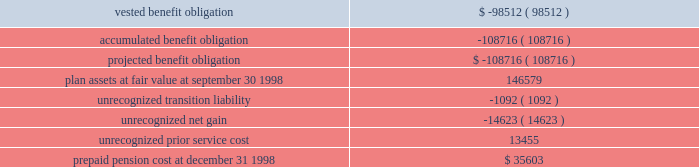The containerboard group ( a division of tenneco packaging inc. ) notes to combined financial statements ( continued ) april 11 , 1999 5 .
Pension and other benefit plans ( continued ) the funded status of the group 2019s allocation of defined benefit plans , excluding the retirement plan , reconciles with amounts recognized in the 1998 statements of assets and liabilities and interdivision account as follows ( in thousands ) : actuarial present value at september 30 , 1998 2014 .
The weighted average discount rate used in determining the actuarial present value of the benefit obligations was 7.00% ( 7.00 % ) for the year ended december 31 , 1998 .
The weighted average expected long-term rate of return on plan assets was 10% ( 10 % ) for 1998 .
Middle management employees participate in a variety of incentive compensation plans .
These plans provide for incentive payments based on the achievement of certain targeted operating results and other specific business goals .
The targeted operating results are determined each year by senior management of packaging .
The amounts charged to expense for these plans were $ 1599000 for the period ended april 11 , 1999 .
In june , 1992 , tenneco initiated an employee stock purchase plan ( 2018 2018espp 2019 2019 ) .
The plan allows u.s .
And canadian employees of the group to purchase tenneco inc .
Common stock through payroll deductions at a 15% ( 15 % ) discount .
Each year , an employee in the plan may purchase shares with a discounted value not to exceed $ 21250 .
The weighted average fair value of the employee purchase right , which was estimated using the black-scholes option pricing model and the assumptions described below except that the average life of each purchase right was assumed to be 90 days , was $ 6.31 for the period ended december 31 , 1998 .
The espp was terminated as of september 30 , 1996 .
Tenneco adopted a new employee stock purchase plan effective april 1 , 1997 .
Under the respective espps , tenneco sold 36883 shares to group employees for the period ended april 11 , 1999 .
In december , 1996 , tenneco adopted the 1996 stock ownership plan , which permits the granting of a variety of awards , including common stock , restricted stock , performance units , stock appreciation rights , and stock options to officers and employees of tenneco .
Tenneco can issue up to 17000000 shares of common stock under this plan , which will terminate december 31 , 2001 .
The april 11 , 1999 , fair market value of the options granted was calculated using tenneco 2019s stock price at the grant date and multiplying the amount by the historical percentage of past black-scholes pricing values fair value ( approximately 25% ( 25 % ) ) .
The fair value of each stock option issued by tenneco to the group in prior periods was estimated on the date of grant using the black-sholes option pricing model using the following ranges of weighted average assumptions for grants during the past three .
Unrecognized prior service cost is what percent of prepaid pension cost as of december 31 1998? 
Computations: (13455 / 35603)
Answer: 0.37792. 